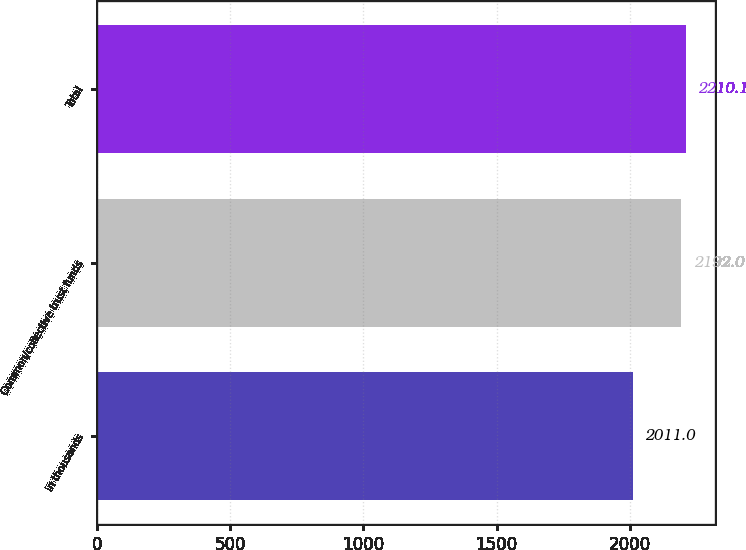Convert chart to OTSL. <chart><loc_0><loc_0><loc_500><loc_500><bar_chart><fcel>in thousands<fcel>Common/collective trust funds<fcel>Total<nl><fcel>2011<fcel>2192<fcel>2210.1<nl></chart> 